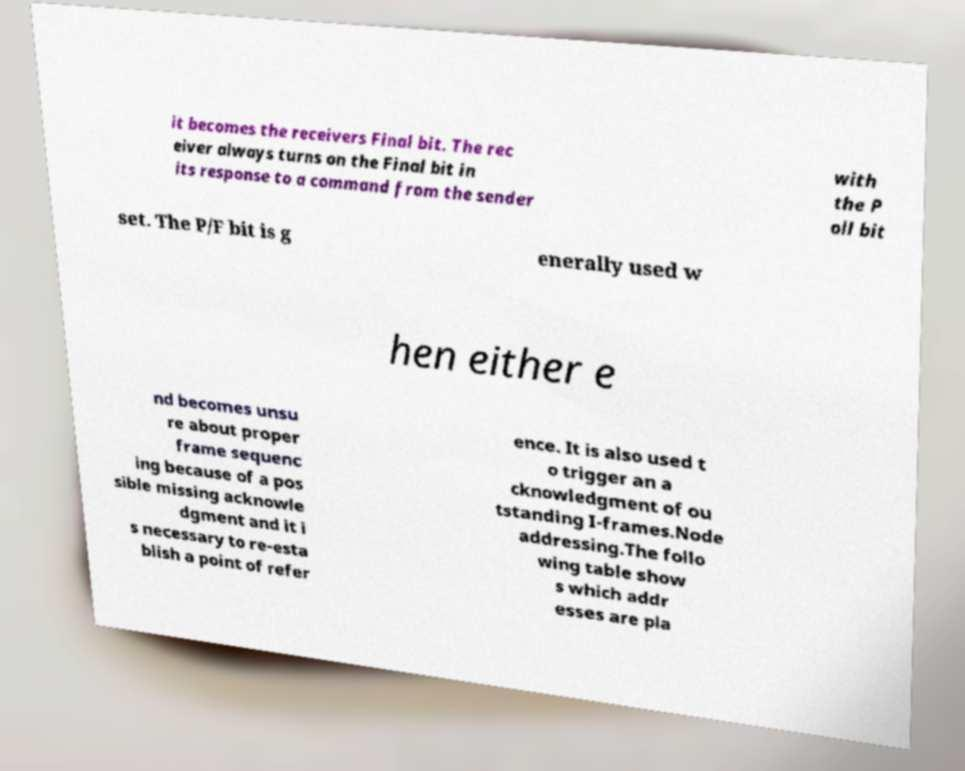Can you read and provide the text displayed in the image?This photo seems to have some interesting text. Can you extract and type it out for me? it becomes the receivers Final bit. The rec eiver always turns on the Final bit in its response to a command from the sender with the P oll bit set. The P/F bit is g enerally used w hen either e nd becomes unsu re about proper frame sequenc ing because of a pos sible missing acknowle dgment and it i s necessary to re-esta blish a point of refer ence. It is also used t o trigger an a cknowledgment of ou tstanding I-frames.Node addressing.The follo wing table show s which addr esses are pla 